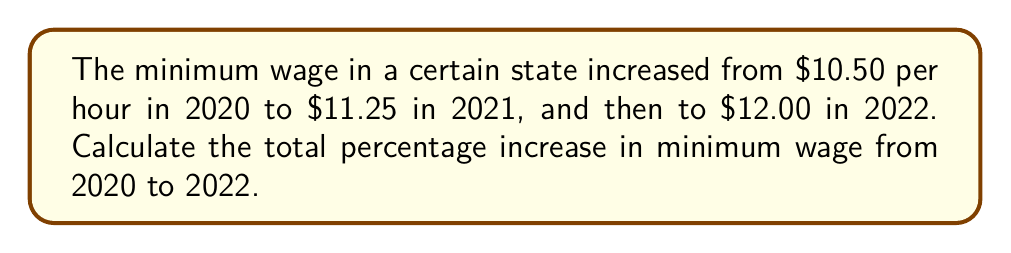Solve this math problem. To calculate the total percentage increase from 2020 to 2022, we'll follow these steps:

1. Calculate the total change in minimum wage:
   $\text{Total change} = \text{Final wage} - \text{Initial wage}$
   $\text{Total change} = $12.00 - $10.50 = $1.50

2. Calculate the percentage increase:
   $\text{Percentage increase} = \frac{\text{Total change}}{\text{Initial wage}} \times 100\%$
   
   $\text{Percentage increase} = \frac{$1.50}{$10.50} \times 100\%$

3. Simplify the fraction:
   $\text{Percentage increase} = \frac{1.50}{10.50} \times 100\%$
   $= \frac{3}{21} \times 100\%$
   $= 0.1428571429 \times 100\%$

4. Calculate the final result:
   $\text{Percentage increase} = 14.29\%$ (rounded to two decimal places)

Therefore, the total percentage increase in minimum wage from 2020 to 2022 is approximately 14.29%.
Answer: 14.29% 